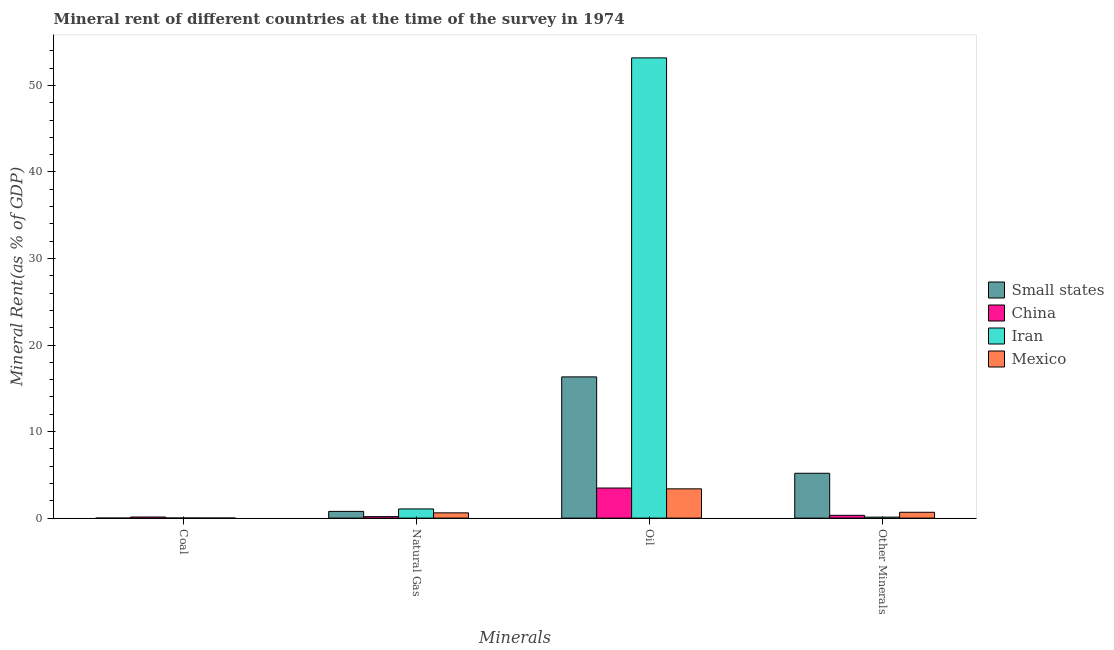Are the number of bars on each tick of the X-axis equal?
Your answer should be very brief. Yes. How many bars are there on the 2nd tick from the right?
Your answer should be compact. 4. What is the label of the 3rd group of bars from the left?
Provide a succinct answer. Oil. What is the  rent of other minerals in Small states?
Provide a short and direct response. 5.18. Across all countries, what is the maximum natural gas rent?
Ensure brevity in your answer.  1.06. Across all countries, what is the minimum natural gas rent?
Offer a very short reply. 0.17. In which country was the coal rent maximum?
Offer a terse response. China. In which country was the coal rent minimum?
Your answer should be compact. Small states. What is the total coal rent in the graph?
Offer a very short reply. 0.15. What is the difference between the  rent of other minerals in Mexico and that in China?
Keep it short and to the point. 0.35. What is the difference between the  rent of other minerals in Small states and the coal rent in Mexico?
Your answer should be compact. 5.18. What is the average natural gas rent per country?
Ensure brevity in your answer.  0.65. What is the difference between the  rent of other minerals and oil rent in Small states?
Keep it short and to the point. -11.14. In how many countries, is the natural gas rent greater than 24 %?
Your answer should be compact. 0. What is the ratio of the coal rent in Small states to that in Mexico?
Your response must be concise. 0.07. Is the natural gas rent in Mexico less than that in Iran?
Make the answer very short. Yes. What is the difference between the highest and the second highest coal rent?
Give a very brief answer. 0.12. What is the difference between the highest and the lowest oil rent?
Your answer should be very brief. 49.8. Is the sum of the  rent of other minerals in Small states and Mexico greater than the maximum oil rent across all countries?
Give a very brief answer. No. Is it the case that in every country, the sum of the natural gas rent and oil rent is greater than the sum of  rent of other minerals and coal rent?
Keep it short and to the point. Yes. What does the 3rd bar from the left in Natural Gas represents?
Ensure brevity in your answer.  Iran. What does the 1st bar from the right in Natural Gas represents?
Keep it short and to the point. Mexico. How many bars are there?
Offer a very short reply. 16. Are all the bars in the graph horizontal?
Your answer should be very brief. No. Are the values on the major ticks of Y-axis written in scientific E-notation?
Keep it short and to the point. No. Does the graph contain any zero values?
Ensure brevity in your answer.  No. Does the graph contain grids?
Offer a terse response. No. How many legend labels are there?
Make the answer very short. 4. What is the title of the graph?
Your answer should be compact. Mineral rent of different countries at the time of the survey in 1974. Does "Cabo Verde" appear as one of the legend labels in the graph?
Make the answer very short. No. What is the label or title of the X-axis?
Ensure brevity in your answer.  Minerals. What is the label or title of the Y-axis?
Your response must be concise. Mineral Rent(as % of GDP). What is the Mineral Rent(as % of GDP) of Small states in Coal?
Your answer should be very brief. 0. What is the Mineral Rent(as % of GDP) of China in Coal?
Give a very brief answer. 0.13. What is the Mineral Rent(as % of GDP) of Iran in Coal?
Give a very brief answer. 0.01. What is the Mineral Rent(as % of GDP) of Mexico in Coal?
Ensure brevity in your answer.  0.01. What is the Mineral Rent(as % of GDP) of Small states in Natural Gas?
Keep it short and to the point. 0.78. What is the Mineral Rent(as % of GDP) of China in Natural Gas?
Offer a very short reply. 0.17. What is the Mineral Rent(as % of GDP) in Iran in Natural Gas?
Provide a succinct answer. 1.06. What is the Mineral Rent(as % of GDP) of Mexico in Natural Gas?
Offer a terse response. 0.61. What is the Mineral Rent(as % of GDP) of Small states in Oil?
Your answer should be compact. 16.32. What is the Mineral Rent(as % of GDP) in China in Oil?
Offer a terse response. 3.48. What is the Mineral Rent(as % of GDP) in Iran in Oil?
Your answer should be compact. 53.18. What is the Mineral Rent(as % of GDP) in Mexico in Oil?
Offer a very short reply. 3.38. What is the Mineral Rent(as % of GDP) in Small states in Other Minerals?
Your answer should be very brief. 5.18. What is the Mineral Rent(as % of GDP) in China in Other Minerals?
Keep it short and to the point. 0.32. What is the Mineral Rent(as % of GDP) in Iran in Other Minerals?
Give a very brief answer. 0.11. What is the Mineral Rent(as % of GDP) of Mexico in Other Minerals?
Ensure brevity in your answer.  0.68. Across all Minerals, what is the maximum Mineral Rent(as % of GDP) of Small states?
Make the answer very short. 16.32. Across all Minerals, what is the maximum Mineral Rent(as % of GDP) of China?
Keep it short and to the point. 3.48. Across all Minerals, what is the maximum Mineral Rent(as % of GDP) of Iran?
Keep it short and to the point. 53.18. Across all Minerals, what is the maximum Mineral Rent(as % of GDP) of Mexico?
Offer a very short reply. 3.38. Across all Minerals, what is the minimum Mineral Rent(as % of GDP) of Small states?
Your answer should be compact. 0. Across all Minerals, what is the minimum Mineral Rent(as % of GDP) in China?
Offer a very short reply. 0.13. Across all Minerals, what is the minimum Mineral Rent(as % of GDP) in Iran?
Provide a succinct answer. 0.01. Across all Minerals, what is the minimum Mineral Rent(as % of GDP) in Mexico?
Offer a terse response. 0.01. What is the total Mineral Rent(as % of GDP) in Small states in the graph?
Your response must be concise. 22.28. What is the total Mineral Rent(as % of GDP) of China in the graph?
Offer a very short reply. 4.1. What is the total Mineral Rent(as % of GDP) of Iran in the graph?
Provide a short and direct response. 54.37. What is the total Mineral Rent(as % of GDP) in Mexico in the graph?
Keep it short and to the point. 4.67. What is the difference between the Mineral Rent(as % of GDP) of Small states in Coal and that in Natural Gas?
Ensure brevity in your answer.  -0.78. What is the difference between the Mineral Rent(as % of GDP) of China in Coal and that in Natural Gas?
Make the answer very short. -0.04. What is the difference between the Mineral Rent(as % of GDP) of Iran in Coal and that in Natural Gas?
Offer a terse response. -1.05. What is the difference between the Mineral Rent(as % of GDP) in Mexico in Coal and that in Natural Gas?
Give a very brief answer. -0.6. What is the difference between the Mineral Rent(as % of GDP) of Small states in Coal and that in Oil?
Give a very brief answer. -16.32. What is the difference between the Mineral Rent(as % of GDP) of China in Coal and that in Oil?
Make the answer very short. -3.35. What is the difference between the Mineral Rent(as % of GDP) of Iran in Coal and that in Oil?
Give a very brief answer. -53.17. What is the difference between the Mineral Rent(as % of GDP) in Mexico in Coal and that in Oil?
Provide a short and direct response. -3.38. What is the difference between the Mineral Rent(as % of GDP) in Small states in Coal and that in Other Minerals?
Your response must be concise. -5.18. What is the difference between the Mineral Rent(as % of GDP) of China in Coal and that in Other Minerals?
Your response must be concise. -0.2. What is the difference between the Mineral Rent(as % of GDP) in Iran in Coal and that in Other Minerals?
Give a very brief answer. -0.1. What is the difference between the Mineral Rent(as % of GDP) of Mexico in Coal and that in Other Minerals?
Keep it short and to the point. -0.67. What is the difference between the Mineral Rent(as % of GDP) in Small states in Natural Gas and that in Oil?
Your answer should be compact. -15.54. What is the difference between the Mineral Rent(as % of GDP) in China in Natural Gas and that in Oil?
Make the answer very short. -3.3. What is the difference between the Mineral Rent(as % of GDP) in Iran in Natural Gas and that in Oil?
Offer a terse response. -52.12. What is the difference between the Mineral Rent(as % of GDP) of Mexico in Natural Gas and that in Oil?
Provide a short and direct response. -2.77. What is the difference between the Mineral Rent(as % of GDP) of Small states in Natural Gas and that in Other Minerals?
Keep it short and to the point. -4.41. What is the difference between the Mineral Rent(as % of GDP) of China in Natural Gas and that in Other Minerals?
Provide a short and direct response. -0.15. What is the difference between the Mineral Rent(as % of GDP) of Iran in Natural Gas and that in Other Minerals?
Ensure brevity in your answer.  0.95. What is the difference between the Mineral Rent(as % of GDP) of Mexico in Natural Gas and that in Other Minerals?
Make the answer very short. -0.07. What is the difference between the Mineral Rent(as % of GDP) of Small states in Oil and that in Other Minerals?
Your answer should be very brief. 11.14. What is the difference between the Mineral Rent(as % of GDP) of China in Oil and that in Other Minerals?
Your answer should be compact. 3.15. What is the difference between the Mineral Rent(as % of GDP) in Iran in Oil and that in Other Minerals?
Give a very brief answer. 53.07. What is the difference between the Mineral Rent(as % of GDP) of Mexico in Oil and that in Other Minerals?
Provide a short and direct response. 2.71. What is the difference between the Mineral Rent(as % of GDP) in Small states in Coal and the Mineral Rent(as % of GDP) in China in Natural Gas?
Offer a very short reply. -0.17. What is the difference between the Mineral Rent(as % of GDP) of Small states in Coal and the Mineral Rent(as % of GDP) of Iran in Natural Gas?
Offer a terse response. -1.06. What is the difference between the Mineral Rent(as % of GDP) of Small states in Coal and the Mineral Rent(as % of GDP) of Mexico in Natural Gas?
Provide a succinct answer. -0.61. What is the difference between the Mineral Rent(as % of GDP) of China in Coal and the Mineral Rent(as % of GDP) of Iran in Natural Gas?
Your response must be concise. -0.93. What is the difference between the Mineral Rent(as % of GDP) in China in Coal and the Mineral Rent(as % of GDP) in Mexico in Natural Gas?
Your answer should be compact. -0.48. What is the difference between the Mineral Rent(as % of GDP) in Iran in Coal and the Mineral Rent(as % of GDP) in Mexico in Natural Gas?
Keep it short and to the point. -0.6. What is the difference between the Mineral Rent(as % of GDP) of Small states in Coal and the Mineral Rent(as % of GDP) of China in Oil?
Your answer should be very brief. -3.48. What is the difference between the Mineral Rent(as % of GDP) in Small states in Coal and the Mineral Rent(as % of GDP) in Iran in Oil?
Make the answer very short. -53.18. What is the difference between the Mineral Rent(as % of GDP) in Small states in Coal and the Mineral Rent(as % of GDP) in Mexico in Oil?
Your answer should be very brief. -3.38. What is the difference between the Mineral Rent(as % of GDP) of China in Coal and the Mineral Rent(as % of GDP) of Iran in Oil?
Provide a succinct answer. -53.06. What is the difference between the Mineral Rent(as % of GDP) in China in Coal and the Mineral Rent(as % of GDP) in Mexico in Oil?
Your answer should be very brief. -3.25. What is the difference between the Mineral Rent(as % of GDP) of Iran in Coal and the Mineral Rent(as % of GDP) of Mexico in Oil?
Provide a succinct answer. -3.37. What is the difference between the Mineral Rent(as % of GDP) of Small states in Coal and the Mineral Rent(as % of GDP) of China in Other Minerals?
Provide a short and direct response. -0.32. What is the difference between the Mineral Rent(as % of GDP) in Small states in Coal and the Mineral Rent(as % of GDP) in Iran in Other Minerals?
Offer a terse response. -0.11. What is the difference between the Mineral Rent(as % of GDP) in Small states in Coal and the Mineral Rent(as % of GDP) in Mexico in Other Minerals?
Make the answer very short. -0.67. What is the difference between the Mineral Rent(as % of GDP) of China in Coal and the Mineral Rent(as % of GDP) of Iran in Other Minerals?
Provide a short and direct response. 0.02. What is the difference between the Mineral Rent(as % of GDP) of China in Coal and the Mineral Rent(as % of GDP) of Mexico in Other Minerals?
Provide a succinct answer. -0.55. What is the difference between the Mineral Rent(as % of GDP) in Iran in Coal and the Mineral Rent(as % of GDP) in Mexico in Other Minerals?
Ensure brevity in your answer.  -0.66. What is the difference between the Mineral Rent(as % of GDP) of Small states in Natural Gas and the Mineral Rent(as % of GDP) of China in Oil?
Give a very brief answer. -2.7. What is the difference between the Mineral Rent(as % of GDP) in Small states in Natural Gas and the Mineral Rent(as % of GDP) in Iran in Oil?
Offer a terse response. -52.41. What is the difference between the Mineral Rent(as % of GDP) of Small states in Natural Gas and the Mineral Rent(as % of GDP) of Mexico in Oil?
Your answer should be very brief. -2.61. What is the difference between the Mineral Rent(as % of GDP) of China in Natural Gas and the Mineral Rent(as % of GDP) of Iran in Oil?
Provide a short and direct response. -53.01. What is the difference between the Mineral Rent(as % of GDP) of China in Natural Gas and the Mineral Rent(as % of GDP) of Mexico in Oil?
Keep it short and to the point. -3.21. What is the difference between the Mineral Rent(as % of GDP) in Iran in Natural Gas and the Mineral Rent(as % of GDP) in Mexico in Oil?
Provide a succinct answer. -2.32. What is the difference between the Mineral Rent(as % of GDP) of Small states in Natural Gas and the Mineral Rent(as % of GDP) of China in Other Minerals?
Give a very brief answer. 0.45. What is the difference between the Mineral Rent(as % of GDP) in Small states in Natural Gas and the Mineral Rent(as % of GDP) in Iran in Other Minerals?
Your answer should be very brief. 0.66. What is the difference between the Mineral Rent(as % of GDP) of Small states in Natural Gas and the Mineral Rent(as % of GDP) of Mexico in Other Minerals?
Offer a very short reply. 0.1. What is the difference between the Mineral Rent(as % of GDP) of China in Natural Gas and the Mineral Rent(as % of GDP) of Iran in Other Minerals?
Your response must be concise. 0.06. What is the difference between the Mineral Rent(as % of GDP) of China in Natural Gas and the Mineral Rent(as % of GDP) of Mexico in Other Minerals?
Ensure brevity in your answer.  -0.5. What is the difference between the Mineral Rent(as % of GDP) of Iran in Natural Gas and the Mineral Rent(as % of GDP) of Mexico in Other Minerals?
Keep it short and to the point. 0.39. What is the difference between the Mineral Rent(as % of GDP) in Small states in Oil and the Mineral Rent(as % of GDP) in China in Other Minerals?
Your answer should be compact. 16. What is the difference between the Mineral Rent(as % of GDP) of Small states in Oil and the Mineral Rent(as % of GDP) of Iran in Other Minerals?
Make the answer very short. 16.21. What is the difference between the Mineral Rent(as % of GDP) of Small states in Oil and the Mineral Rent(as % of GDP) of Mexico in Other Minerals?
Provide a succinct answer. 15.65. What is the difference between the Mineral Rent(as % of GDP) in China in Oil and the Mineral Rent(as % of GDP) in Iran in Other Minerals?
Your answer should be compact. 3.36. What is the difference between the Mineral Rent(as % of GDP) of China in Oil and the Mineral Rent(as % of GDP) of Mexico in Other Minerals?
Keep it short and to the point. 2.8. What is the difference between the Mineral Rent(as % of GDP) in Iran in Oil and the Mineral Rent(as % of GDP) in Mexico in Other Minerals?
Give a very brief answer. 52.51. What is the average Mineral Rent(as % of GDP) of Small states per Minerals?
Offer a terse response. 5.57. What is the average Mineral Rent(as % of GDP) of China per Minerals?
Provide a short and direct response. 1.02. What is the average Mineral Rent(as % of GDP) of Iran per Minerals?
Provide a succinct answer. 13.59. What is the average Mineral Rent(as % of GDP) of Mexico per Minerals?
Your response must be concise. 1.17. What is the difference between the Mineral Rent(as % of GDP) of Small states and Mineral Rent(as % of GDP) of China in Coal?
Give a very brief answer. -0.13. What is the difference between the Mineral Rent(as % of GDP) of Small states and Mineral Rent(as % of GDP) of Iran in Coal?
Ensure brevity in your answer.  -0.01. What is the difference between the Mineral Rent(as % of GDP) in Small states and Mineral Rent(as % of GDP) in Mexico in Coal?
Keep it short and to the point. -0.01. What is the difference between the Mineral Rent(as % of GDP) in China and Mineral Rent(as % of GDP) in Iran in Coal?
Provide a short and direct response. 0.12. What is the difference between the Mineral Rent(as % of GDP) in China and Mineral Rent(as % of GDP) in Mexico in Coal?
Your answer should be compact. 0.12. What is the difference between the Mineral Rent(as % of GDP) in Iran and Mineral Rent(as % of GDP) in Mexico in Coal?
Your answer should be compact. 0. What is the difference between the Mineral Rent(as % of GDP) in Small states and Mineral Rent(as % of GDP) in China in Natural Gas?
Your response must be concise. 0.6. What is the difference between the Mineral Rent(as % of GDP) in Small states and Mineral Rent(as % of GDP) in Iran in Natural Gas?
Your answer should be compact. -0.28. What is the difference between the Mineral Rent(as % of GDP) of Small states and Mineral Rent(as % of GDP) of Mexico in Natural Gas?
Offer a terse response. 0.17. What is the difference between the Mineral Rent(as % of GDP) in China and Mineral Rent(as % of GDP) in Iran in Natural Gas?
Give a very brief answer. -0.89. What is the difference between the Mineral Rent(as % of GDP) in China and Mineral Rent(as % of GDP) in Mexico in Natural Gas?
Your answer should be compact. -0.44. What is the difference between the Mineral Rent(as % of GDP) of Iran and Mineral Rent(as % of GDP) of Mexico in Natural Gas?
Offer a terse response. 0.45. What is the difference between the Mineral Rent(as % of GDP) of Small states and Mineral Rent(as % of GDP) of China in Oil?
Your answer should be very brief. 12.85. What is the difference between the Mineral Rent(as % of GDP) of Small states and Mineral Rent(as % of GDP) of Iran in Oil?
Give a very brief answer. -36.86. What is the difference between the Mineral Rent(as % of GDP) of Small states and Mineral Rent(as % of GDP) of Mexico in Oil?
Ensure brevity in your answer.  12.94. What is the difference between the Mineral Rent(as % of GDP) of China and Mineral Rent(as % of GDP) of Iran in Oil?
Your answer should be compact. -49.71. What is the difference between the Mineral Rent(as % of GDP) of China and Mineral Rent(as % of GDP) of Mexico in Oil?
Give a very brief answer. 0.09. What is the difference between the Mineral Rent(as % of GDP) of Iran and Mineral Rent(as % of GDP) of Mexico in Oil?
Provide a succinct answer. 49.8. What is the difference between the Mineral Rent(as % of GDP) in Small states and Mineral Rent(as % of GDP) in China in Other Minerals?
Ensure brevity in your answer.  4.86. What is the difference between the Mineral Rent(as % of GDP) of Small states and Mineral Rent(as % of GDP) of Iran in Other Minerals?
Keep it short and to the point. 5.07. What is the difference between the Mineral Rent(as % of GDP) of Small states and Mineral Rent(as % of GDP) of Mexico in Other Minerals?
Keep it short and to the point. 4.51. What is the difference between the Mineral Rent(as % of GDP) in China and Mineral Rent(as % of GDP) in Iran in Other Minerals?
Your response must be concise. 0.21. What is the difference between the Mineral Rent(as % of GDP) of China and Mineral Rent(as % of GDP) of Mexico in Other Minerals?
Offer a terse response. -0.35. What is the difference between the Mineral Rent(as % of GDP) in Iran and Mineral Rent(as % of GDP) in Mexico in Other Minerals?
Keep it short and to the point. -0.56. What is the ratio of the Mineral Rent(as % of GDP) of Small states in Coal to that in Natural Gas?
Provide a succinct answer. 0. What is the ratio of the Mineral Rent(as % of GDP) of China in Coal to that in Natural Gas?
Your answer should be compact. 0.75. What is the ratio of the Mineral Rent(as % of GDP) of Iran in Coal to that in Natural Gas?
Your answer should be compact. 0.01. What is the ratio of the Mineral Rent(as % of GDP) in Mexico in Coal to that in Natural Gas?
Your answer should be compact. 0.01. What is the ratio of the Mineral Rent(as % of GDP) in Small states in Coal to that in Oil?
Make the answer very short. 0. What is the ratio of the Mineral Rent(as % of GDP) in China in Coal to that in Oil?
Give a very brief answer. 0.04. What is the ratio of the Mineral Rent(as % of GDP) of Iran in Coal to that in Oil?
Provide a succinct answer. 0. What is the ratio of the Mineral Rent(as % of GDP) of Mexico in Coal to that in Oil?
Provide a short and direct response. 0. What is the ratio of the Mineral Rent(as % of GDP) of Small states in Coal to that in Other Minerals?
Provide a short and direct response. 0. What is the ratio of the Mineral Rent(as % of GDP) of China in Coal to that in Other Minerals?
Offer a very short reply. 0.4. What is the ratio of the Mineral Rent(as % of GDP) of Iran in Coal to that in Other Minerals?
Your answer should be very brief. 0.09. What is the ratio of the Mineral Rent(as % of GDP) of Mexico in Coal to that in Other Minerals?
Offer a very short reply. 0.01. What is the ratio of the Mineral Rent(as % of GDP) of Small states in Natural Gas to that in Oil?
Ensure brevity in your answer.  0.05. What is the ratio of the Mineral Rent(as % of GDP) of China in Natural Gas to that in Oil?
Ensure brevity in your answer.  0.05. What is the ratio of the Mineral Rent(as % of GDP) of Iran in Natural Gas to that in Oil?
Offer a terse response. 0.02. What is the ratio of the Mineral Rent(as % of GDP) of Mexico in Natural Gas to that in Oil?
Your answer should be very brief. 0.18. What is the ratio of the Mineral Rent(as % of GDP) in Small states in Natural Gas to that in Other Minerals?
Your response must be concise. 0.15. What is the ratio of the Mineral Rent(as % of GDP) of China in Natural Gas to that in Other Minerals?
Keep it short and to the point. 0.53. What is the ratio of the Mineral Rent(as % of GDP) of Iran in Natural Gas to that in Other Minerals?
Your answer should be very brief. 9.38. What is the ratio of the Mineral Rent(as % of GDP) of Mexico in Natural Gas to that in Other Minerals?
Keep it short and to the point. 0.9. What is the ratio of the Mineral Rent(as % of GDP) in Small states in Oil to that in Other Minerals?
Make the answer very short. 3.15. What is the ratio of the Mineral Rent(as % of GDP) in China in Oil to that in Other Minerals?
Your answer should be very brief. 10.74. What is the ratio of the Mineral Rent(as % of GDP) of Iran in Oil to that in Other Minerals?
Make the answer very short. 470.24. What is the ratio of the Mineral Rent(as % of GDP) of Mexico in Oil to that in Other Minerals?
Keep it short and to the point. 5.01. What is the difference between the highest and the second highest Mineral Rent(as % of GDP) of Small states?
Ensure brevity in your answer.  11.14. What is the difference between the highest and the second highest Mineral Rent(as % of GDP) in China?
Make the answer very short. 3.15. What is the difference between the highest and the second highest Mineral Rent(as % of GDP) of Iran?
Make the answer very short. 52.12. What is the difference between the highest and the second highest Mineral Rent(as % of GDP) of Mexico?
Ensure brevity in your answer.  2.71. What is the difference between the highest and the lowest Mineral Rent(as % of GDP) of Small states?
Keep it short and to the point. 16.32. What is the difference between the highest and the lowest Mineral Rent(as % of GDP) of China?
Offer a very short reply. 3.35. What is the difference between the highest and the lowest Mineral Rent(as % of GDP) in Iran?
Provide a succinct answer. 53.17. What is the difference between the highest and the lowest Mineral Rent(as % of GDP) of Mexico?
Your answer should be compact. 3.38. 